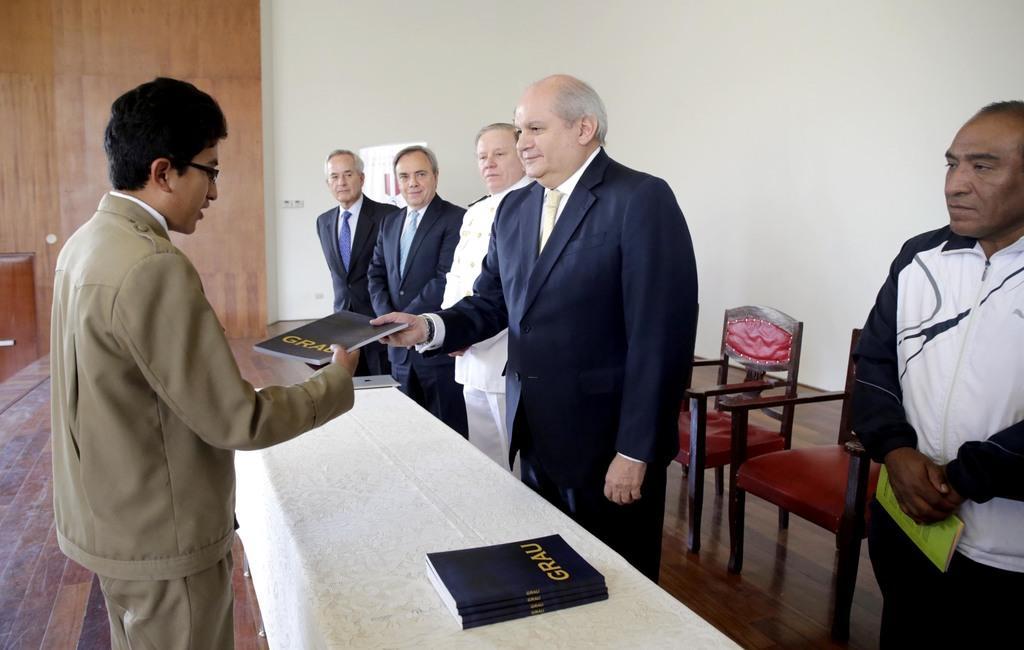Describe this image in one or two sentences. This is an image clicked inside the room. In this image I can see one person is giving one to the other person who is standing in front of him. There are few more people standing beside this person. In the background there is a wall. On the bottom of the image there is a table covered with a white cloth and there are few books on this table. On the right side of the image I can see two red color chairs. 